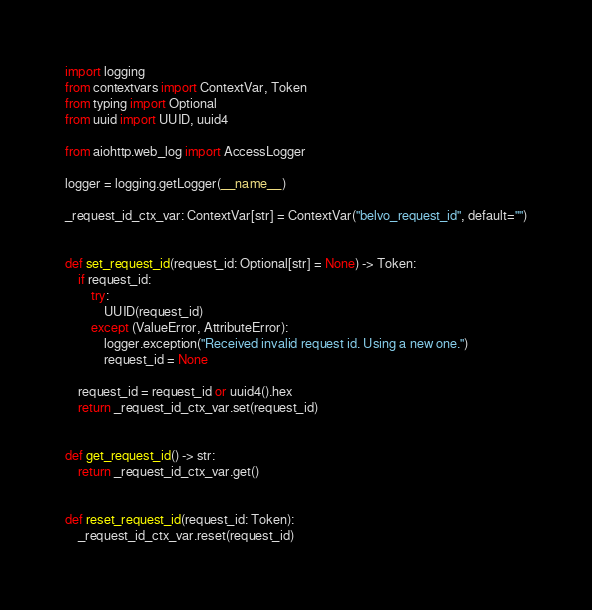<code> <loc_0><loc_0><loc_500><loc_500><_Python_>import logging
from contextvars import ContextVar, Token
from typing import Optional
from uuid import UUID, uuid4

from aiohttp.web_log import AccessLogger

logger = logging.getLogger(__name__)

_request_id_ctx_var: ContextVar[str] = ContextVar("belvo_request_id", default="")


def set_request_id(request_id: Optional[str] = None) -> Token:
    if request_id:
        try:
            UUID(request_id)
        except (ValueError, AttributeError):
            logger.exception("Received invalid request id. Using a new one.")
            request_id = None

    request_id = request_id or uuid4().hex
    return _request_id_ctx_var.set(request_id)


def get_request_id() -> str:
    return _request_id_ctx_var.get()


def reset_request_id(request_id: Token):
    _request_id_ctx_var.reset(request_id)
</code> 